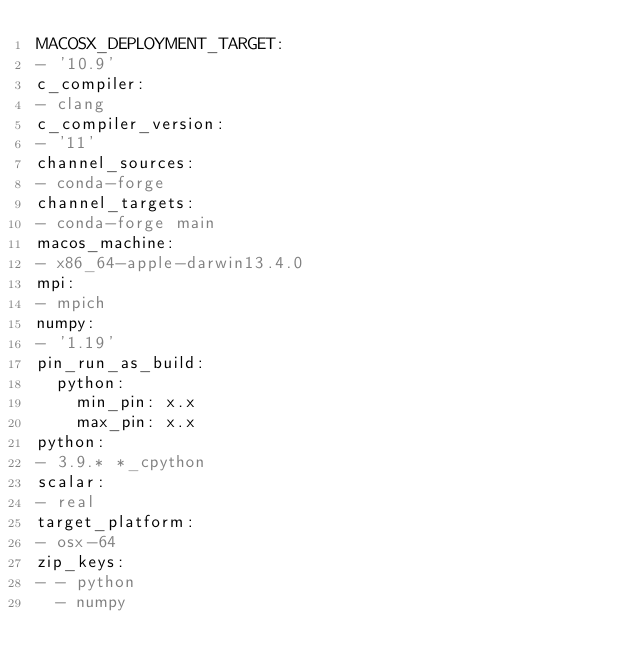<code> <loc_0><loc_0><loc_500><loc_500><_YAML_>MACOSX_DEPLOYMENT_TARGET:
- '10.9'
c_compiler:
- clang
c_compiler_version:
- '11'
channel_sources:
- conda-forge
channel_targets:
- conda-forge main
macos_machine:
- x86_64-apple-darwin13.4.0
mpi:
- mpich
numpy:
- '1.19'
pin_run_as_build:
  python:
    min_pin: x.x
    max_pin: x.x
python:
- 3.9.* *_cpython
scalar:
- real
target_platform:
- osx-64
zip_keys:
- - python
  - numpy
</code> 